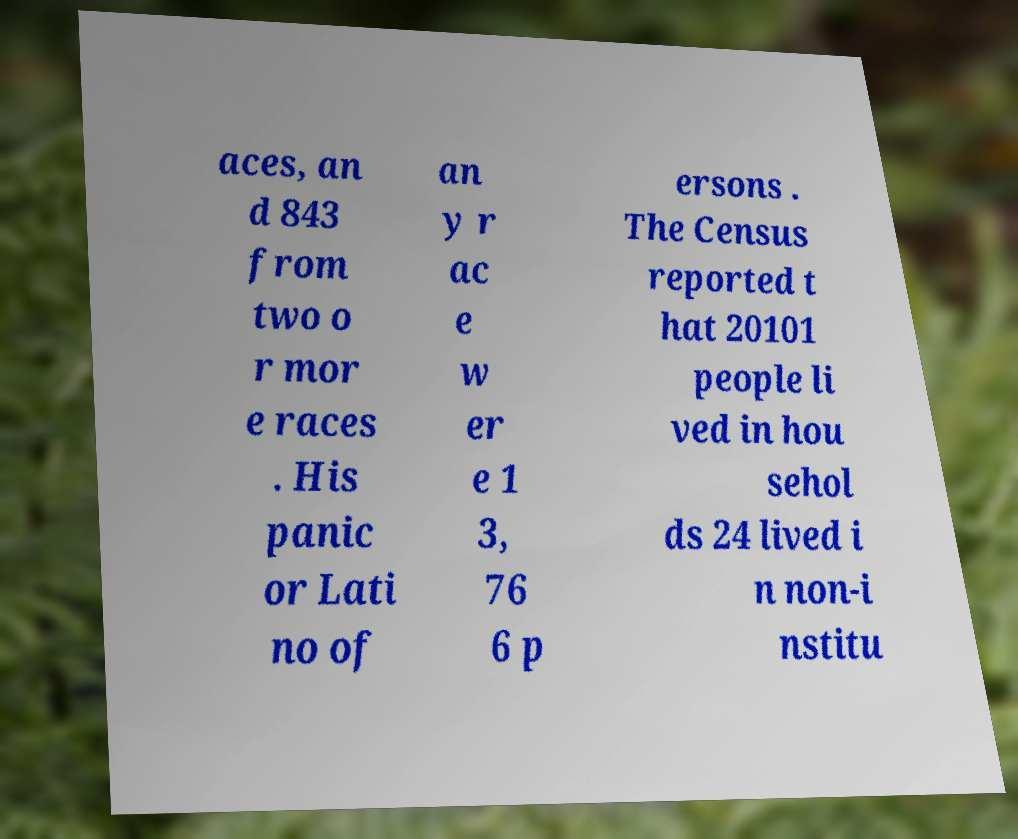What messages or text are displayed in this image? I need them in a readable, typed format. aces, an d 843 from two o r mor e races . His panic or Lati no of an y r ac e w er e 1 3, 76 6 p ersons . The Census reported t hat 20101 people li ved in hou sehol ds 24 lived i n non-i nstitu 